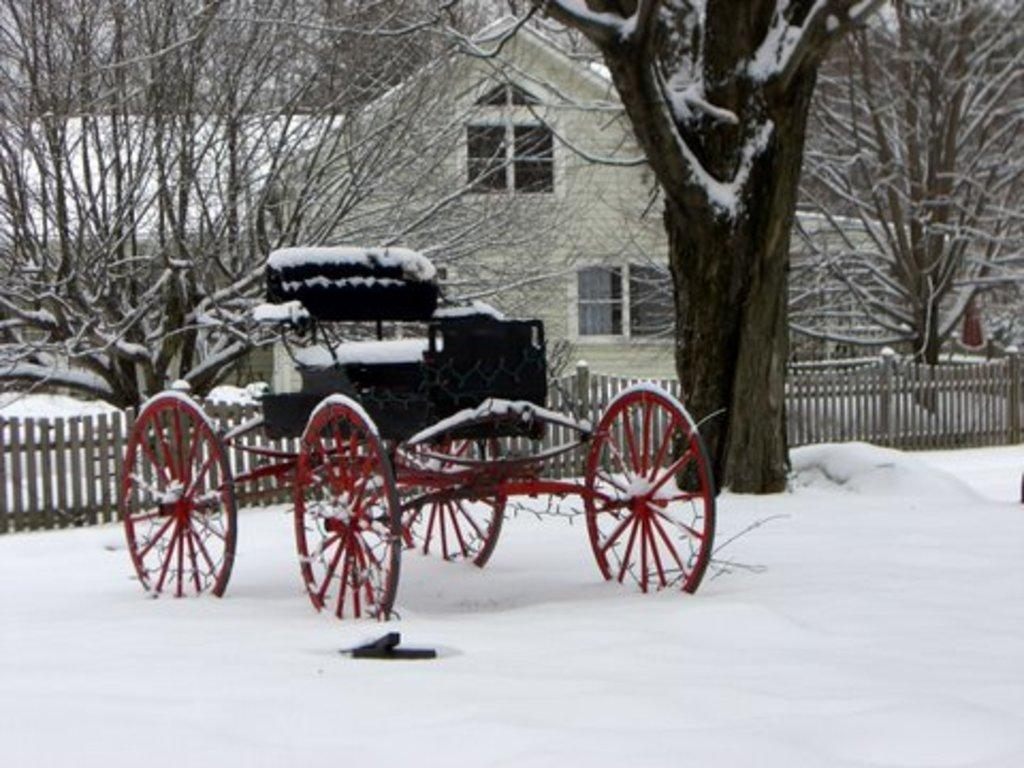What is located in the foreground of the picture? There is a cart in the foreground of the picture, and there is also snow in the foreground. What can be seen in the center of the picture? There are trees, a house, and a railing in the center of the picture. What is visible in the background of the picture? There are trees in the background of the picture. Can you see a mark on the cart in the image? There is no mention of a mark on the cart in the provided facts, so we cannot determine if it is present in the image. Is there a net hanging from the trees in the background? There is no mention of a net in the provided facts, so we cannot determine if it is present in the image. 